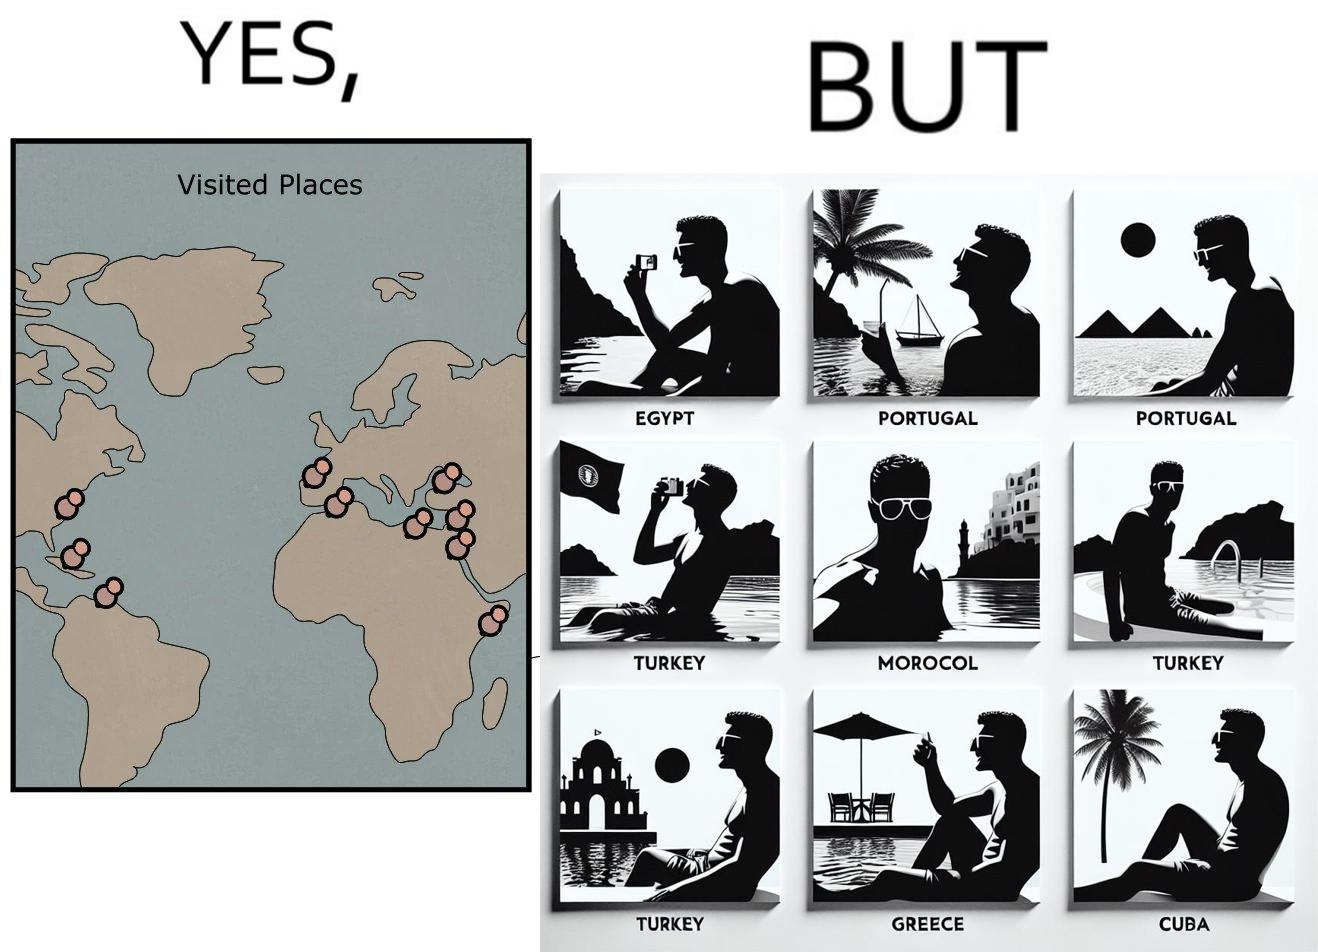What do you see in each half of this image? In the left part of the image: The image shows a map with pins set on places which have been visited by a person. In the right part of the image: The image shows several photos of a man wearing sunglasses  inside a pool in various countries like Egypt, Portugal, Morocco, Turkey, Greece and Cuba. 